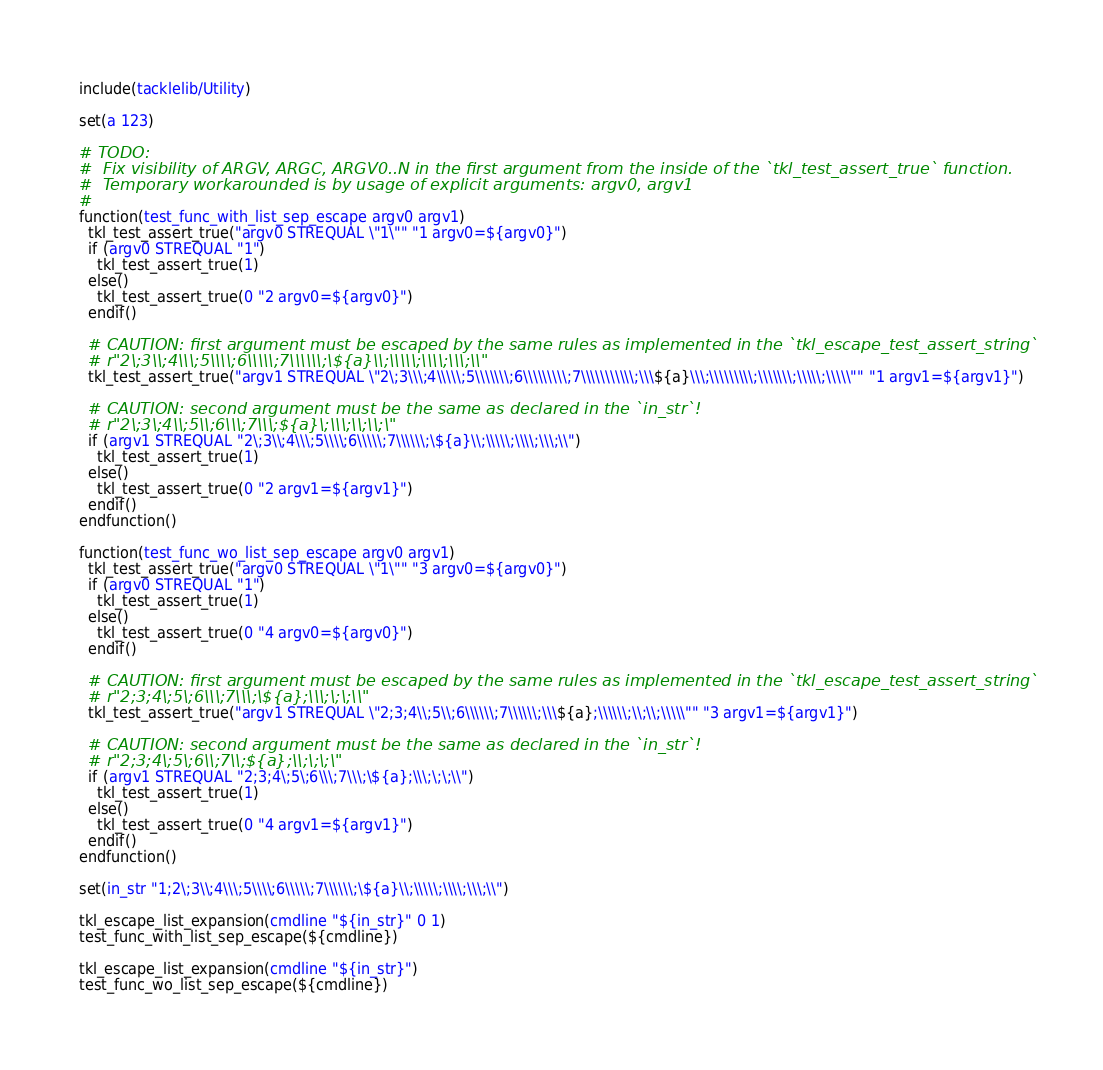<code> <loc_0><loc_0><loc_500><loc_500><_CMake_>include(tacklelib/Utility)

set(a 123)

# TODO:
#  Fix visibility of ARGV, ARGC, ARGV0..N in the first argument from the inside of the `tkl_test_assert_true` function.
#  Temporary workarounded is by usage of explicit arguments: argv0, argv1
#
function(test_func_with_list_sep_escape argv0 argv1)
  tkl_test_assert_true("argv0 STREQUAL \"1\"" "1 argv0=${argv0}")
  if (argv0 STREQUAL "1")
    tkl_test_assert_true(1)
  else()
    tkl_test_assert_true(0 "2 argv0=${argv0}")
  endif()

  # CAUTION: first argument must be escaped by the same rules as implemented in the `tkl_escape_test_assert_string`
  # r"2\;3\\;4\\\;5\\\\;6\\\\\;7\\\\\\;\${a}\\;\\\\\;\\\\;\\\;\\"
  tkl_test_assert_true("argv1 STREQUAL \"2\;3\\\;4\\\\\;5\\\\\\\;6\\\\\\\\\;7\\\\\\\\\\\;\\\${a}\\\;\\\\\\\\\;\\\\\\\;\\\\\;\\\\\"" "1 argv1=${argv1}")

  # CAUTION: second argument must be the same as declared in the `in_str`!
  # r"2\;3\;4\\;5\\;6\\\;7\\\;${a}\;\\\;\\;\\;\"
  if (argv1 STREQUAL "2\;3\\;4\\\;5\\\\;6\\\\\;7\\\\\\;\${a}\\;\\\\\;\\\\;\\\;\\")
    tkl_test_assert_true(1)
  else()
    tkl_test_assert_true(0 "2 argv1=${argv1}")
  endif()
endfunction()

function(test_func_wo_list_sep_escape argv0 argv1)
  tkl_test_assert_true("argv0 STREQUAL \"1\"" "3 argv0=${argv0}")
  if (argv0 STREQUAL "1")
    tkl_test_assert_true(1)
  else()
    tkl_test_assert_true(0 "4 argv0=${argv0}")
  endif()

  # CAUTION: first argument must be escaped by the same rules as implemented in the `tkl_escape_test_assert_string`
  # r"2;3;4\;5\;6\\\;7\\\;\${a};\\\;\;\;\\"
  tkl_test_assert_true("argv1 STREQUAL \"2;3;4\\;5\\;6\\\\\\;7\\\\\\;\\\${a};\\\\\\;\\;\\;\\\\\"" "3 argv1=${argv1}")

  # CAUTION: second argument must be the same as declared in the `in_str`!
  # r"2;3;4\;5\;6\\;7\\;${a};\\;\;\;\"
  if (argv1 STREQUAL "2;3;4\;5\;6\\\;7\\\;\${a};\\\;\;\;\\")
    tkl_test_assert_true(1)
  else()
    tkl_test_assert_true(0 "4 argv1=${argv1}")
  endif()
endfunction()

set(in_str "1;2\;3\\;4\\\;5\\\\;6\\\\\;7\\\\\\;\${a}\\;\\\\\;\\\\;\\\;\\")

tkl_escape_list_expansion(cmdline "${in_str}" 0 1)
test_func_with_list_sep_escape(${cmdline})

tkl_escape_list_expansion(cmdline "${in_str}")
test_func_wo_list_sep_escape(${cmdline})
</code> 